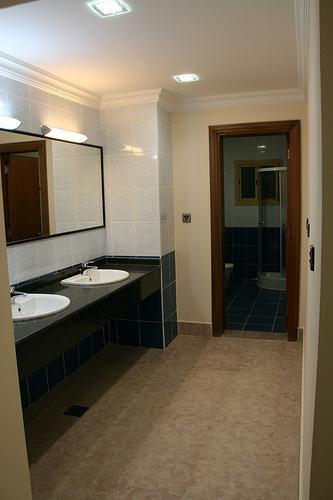Question: how many sinks are shown?
Choices:
A. 2.
B. 1.
C. 3.
D. 4.
Answer with the letter. Answer: A Question: where is this picture taken?
Choices:
A. Bedroom.
B. A bathroom.
C. Living room.
D. Kitchen.
Answer with the letter. Answer: B Question: what color are the counters?
Choices:
A. Brown.
B. Black.
C. White.
D. Gray.
Answer with the letter. Answer: B Question: what hangs above the sinks?
Choices:
A. A mirror.
B. Cabinets.
C. Doors.
D. Picture.
Answer with the letter. Answer: A 